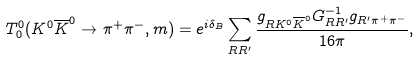<formula> <loc_0><loc_0><loc_500><loc_500>T _ { 0 } ^ { 0 } ( K ^ { 0 } \overline { K } ^ { 0 } \to \pi ^ { + } \pi ^ { - } , m ) = e ^ { i \delta _ { B } } \sum _ { R R ^ { \prime } } \frac { g _ { R K ^ { 0 } \overline { K } ^ { 0 } } G ^ { - 1 } _ { R R ^ { \prime } } g _ { R ^ { \prime } \pi ^ { + } \pi ^ { - } } } { 1 6 \pi } ,</formula> 